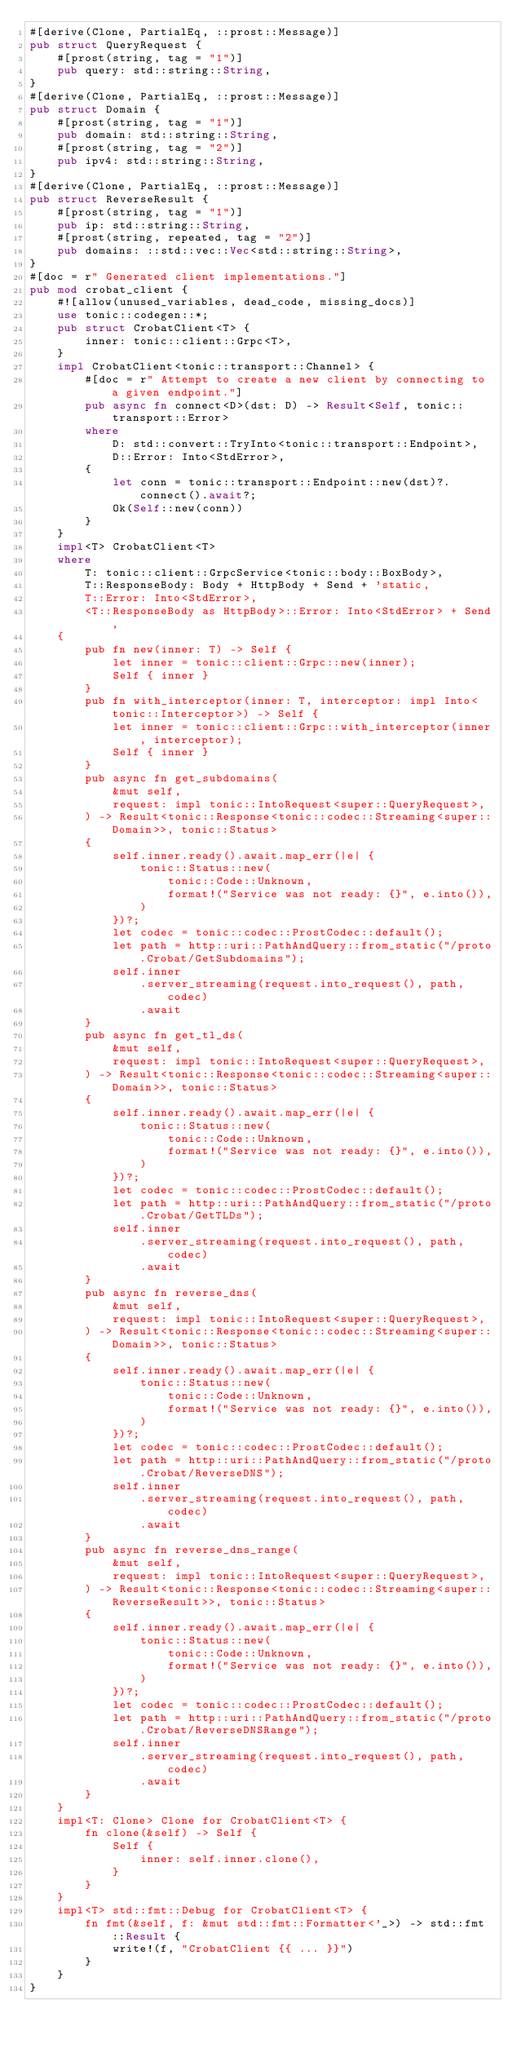Convert code to text. <code><loc_0><loc_0><loc_500><loc_500><_Rust_>#[derive(Clone, PartialEq, ::prost::Message)]
pub struct QueryRequest {
    #[prost(string, tag = "1")]
    pub query: std::string::String,
}
#[derive(Clone, PartialEq, ::prost::Message)]
pub struct Domain {
    #[prost(string, tag = "1")]
    pub domain: std::string::String,
    #[prost(string, tag = "2")]
    pub ipv4: std::string::String,
}
#[derive(Clone, PartialEq, ::prost::Message)]
pub struct ReverseResult {
    #[prost(string, tag = "1")]
    pub ip: std::string::String,
    #[prost(string, repeated, tag = "2")]
    pub domains: ::std::vec::Vec<std::string::String>,
}
#[doc = r" Generated client implementations."]
pub mod crobat_client {
    #![allow(unused_variables, dead_code, missing_docs)]
    use tonic::codegen::*;
    pub struct CrobatClient<T> {
        inner: tonic::client::Grpc<T>,
    }
    impl CrobatClient<tonic::transport::Channel> {
        #[doc = r" Attempt to create a new client by connecting to a given endpoint."]
        pub async fn connect<D>(dst: D) -> Result<Self, tonic::transport::Error>
        where
            D: std::convert::TryInto<tonic::transport::Endpoint>,
            D::Error: Into<StdError>,
        {
            let conn = tonic::transport::Endpoint::new(dst)?.connect().await?;
            Ok(Self::new(conn))
        }
    }
    impl<T> CrobatClient<T>
    where
        T: tonic::client::GrpcService<tonic::body::BoxBody>,
        T::ResponseBody: Body + HttpBody + Send + 'static,
        T::Error: Into<StdError>,
        <T::ResponseBody as HttpBody>::Error: Into<StdError> + Send,
    {
        pub fn new(inner: T) -> Self {
            let inner = tonic::client::Grpc::new(inner);
            Self { inner }
        }
        pub fn with_interceptor(inner: T, interceptor: impl Into<tonic::Interceptor>) -> Self {
            let inner = tonic::client::Grpc::with_interceptor(inner, interceptor);
            Self { inner }
        }
        pub async fn get_subdomains(
            &mut self,
            request: impl tonic::IntoRequest<super::QueryRequest>,
        ) -> Result<tonic::Response<tonic::codec::Streaming<super::Domain>>, tonic::Status>
        {
            self.inner.ready().await.map_err(|e| {
                tonic::Status::new(
                    tonic::Code::Unknown,
                    format!("Service was not ready: {}", e.into()),
                )
            })?;
            let codec = tonic::codec::ProstCodec::default();
            let path = http::uri::PathAndQuery::from_static("/proto.Crobat/GetSubdomains");
            self.inner
                .server_streaming(request.into_request(), path, codec)
                .await
        }
        pub async fn get_tl_ds(
            &mut self,
            request: impl tonic::IntoRequest<super::QueryRequest>,
        ) -> Result<tonic::Response<tonic::codec::Streaming<super::Domain>>, tonic::Status>
        {
            self.inner.ready().await.map_err(|e| {
                tonic::Status::new(
                    tonic::Code::Unknown,
                    format!("Service was not ready: {}", e.into()),
                )
            })?;
            let codec = tonic::codec::ProstCodec::default();
            let path = http::uri::PathAndQuery::from_static("/proto.Crobat/GetTLDs");
            self.inner
                .server_streaming(request.into_request(), path, codec)
                .await
        }
        pub async fn reverse_dns(
            &mut self,
            request: impl tonic::IntoRequest<super::QueryRequest>,
        ) -> Result<tonic::Response<tonic::codec::Streaming<super::Domain>>, tonic::Status>
        {
            self.inner.ready().await.map_err(|e| {
                tonic::Status::new(
                    tonic::Code::Unknown,
                    format!("Service was not ready: {}", e.into()),
                )
            })?;
            let codec = tonic::codec::ProstCodec::default();
            let path = http::uri::PathAndQuery::from_static("/proto.Crobat/ReverseDNS");
            self.inner
                .server_streaming(request.into_request(), path, codec)
                .await
        }
        pub async fn reverse_dns_range(
            &mut self,
            request: impl tonic::IntoRequest<super::QueryRequest>,
        ) -> Result<tonic::Response<tonic::codec::Streaming<super::ReverseResult>>, tonic::Status>
        {
            self.inner.ready().await.map_err(|e| {
                tonic::Status::new(
                    tonic::Code::Unknown,
                    format!("Service was not ready: {}", e.into()),
                )
            })?;
            let codec = tonic::codec::ProstCodec::default();
            let path = http::uri::PathAndQuery::from_static("/proto.Crobat/ReverseDNSRange");
            self.inner
                .server_streaming(request.into_request(), path, codec)
                .await
        }
    }
    impl<T: Clone> Clone for CrobatClient<T> {
        fn clone(&self) -> Self {
            Self {
                inner: self.inner.clone(),
            }
        }
    }
    impl<T> std::fmt::Debug for CrobatClient<T> {
        fn fmt(&self, f: &mut std::fmt::Formatter<'_>) -> std::fmt::Result {
            write!(f, "CrobatClient {{ ... }}")
        }
    }
}
</code> 